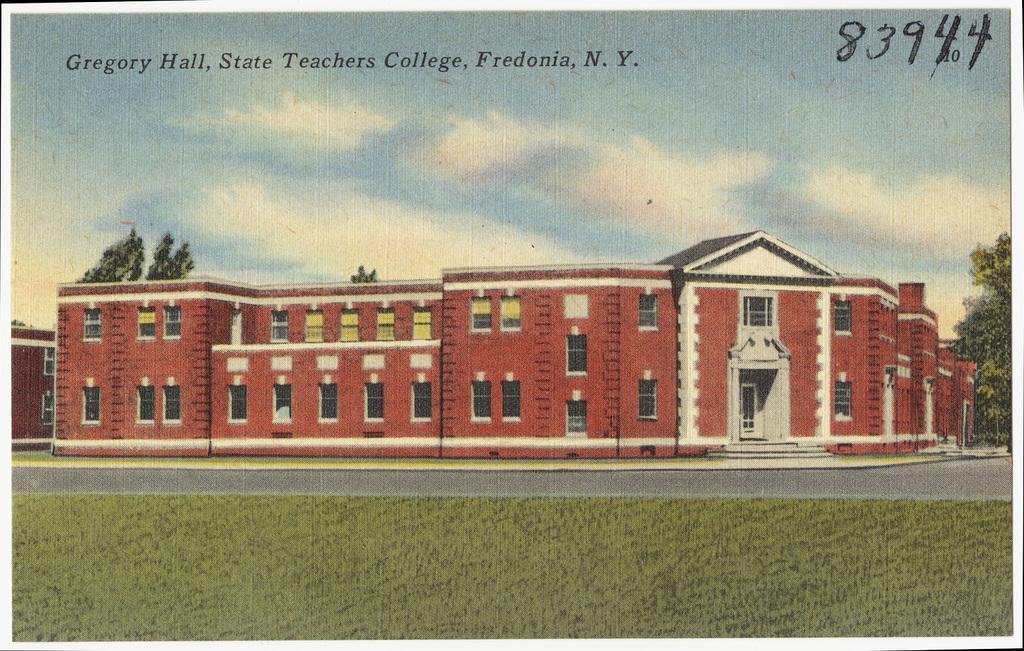In one or two sentences, can you explain what this image depicts? This image is a poster. In this image there is a building with windows and doors. At the bottom of the image there is grass and road. There are trees. At the top of the image there is text, sky and clouds. 